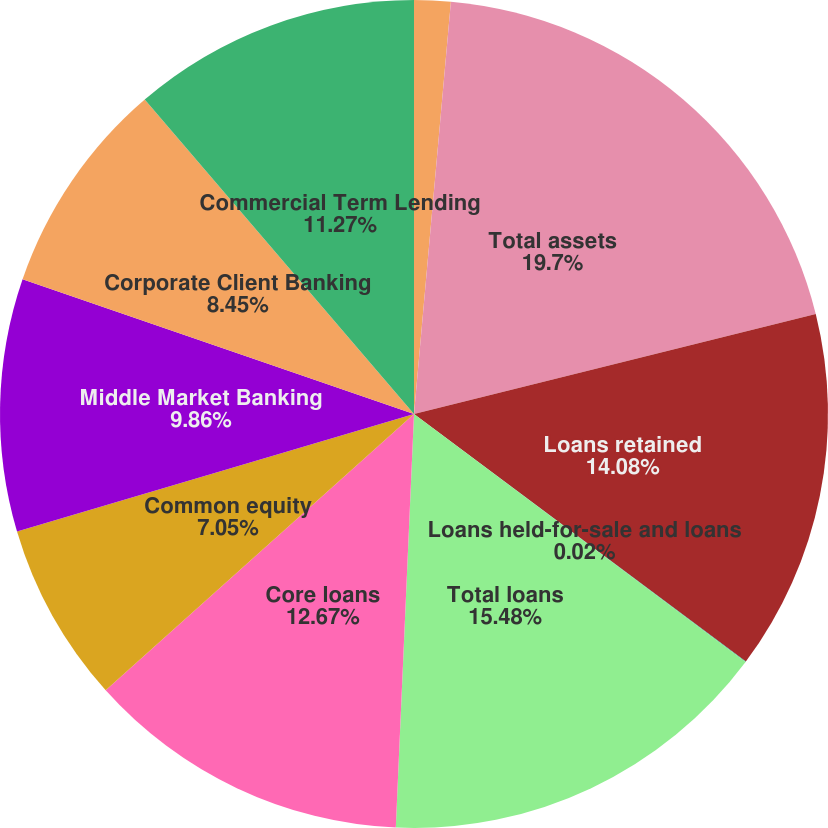Convert chart to OTSL. <chart><loc_0><loc_0><loc_500><loc_500><pie_chart><fcel>As of or for the year ended<fcel>Total assets<fcel>Loans retained<fcel>Loans held-for-sale and loans<fcel>Total loans<fcel>Core loans<fcel>Common equity<fcel>Middle Market Banking<fcel>Corporate Client Banking<fcel>Commercial Term Lending<nl><fcel>1.42%<fcel>19.7%<fcel>14.08%<fcel>0.02%<fcel>15.48%<fcel>12.67%<fcel>7.05%<fcel>9.86%<fcel>8.45%<fcel>11.27%<nl></chart> 